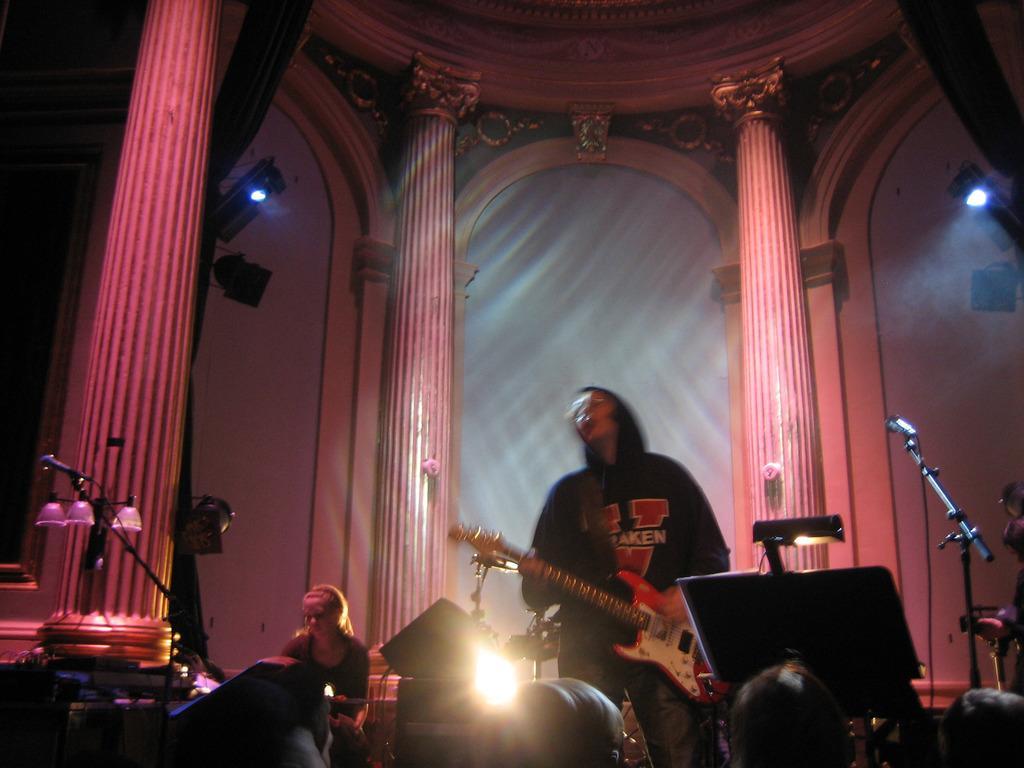Can you describe this image briefly? In the image i can see inside view of a building. and i can see a right side light is visible. on the right corner i can see a mike ,and middle i can see a person wearing a black color shirt and holding a guitar, and on the left side there is a light. And there is a beam on the left side. And on the middle another woman sit on the chair. 